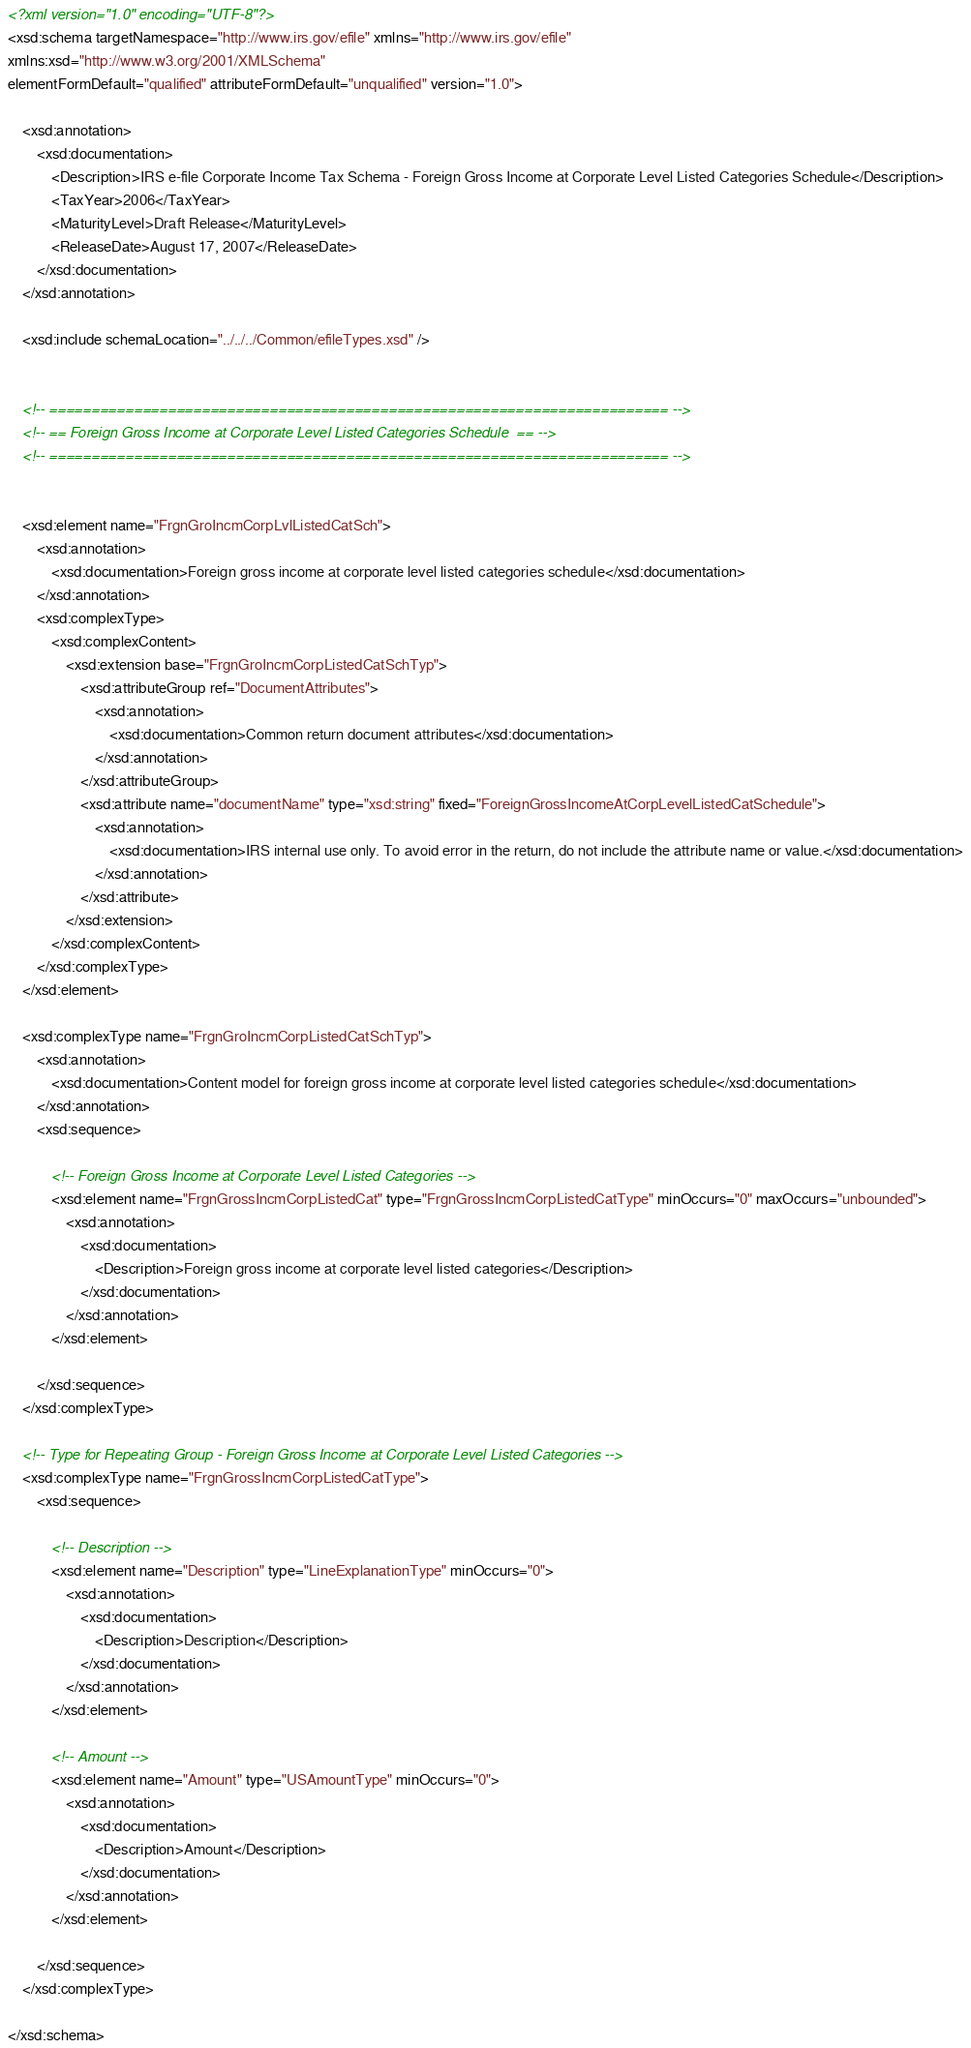<code> <loc_0><loc_0><loc_500><loc_500><_XML_><?xml version="1.0" encoding="UTF-8"?>
<xsd:schema targetNamespace="http://www.irs.gov/efile" xmlns="http://www.irs.gov/efile" 
xmlns:xsd="http://www.w3.org/2001/XMLSchema" 
elementFormDefault="qualified" attributeFormDefault="unqualified" version="1.0">

	<xsd:annotation>
		<xsd:documentation>
			<Description>IRS e-file Corporate Income Tax Schema - Foreign Gross Income at Corporate Level Listed Categories Schedule</Description>
			<TaxYear>2006</TaxYear>
			<MaturityLevel>Draft Release</MaturityLevel>
			<ReleaseDate>August 17, 2007</ReleaseDate>
		</xsd:documentation>
	</xsd:annotation>

	<xsd:include schemaLocation="../../../Common/efileTypes.xsd" />


	<!-- ========================================================================= -->
	<!-- == Foreign Gross Income at Corporate Level Listed Categories Schedule  == -->
	<!-- ========================================================================= -->


	<xsd:element name="FrgnGroIncmCorpLvlListedCatSch">
		<xsd:annotation>
			<xsd:documentation>Foreign gross income at corporate level listed categories schedule</xsd:documentation>
		</xsd:annotation>
		<xsd:complexType>
			<xsd:complexContent>
				<xsd:extension base="FrgnGroIncmCorpListedCatSchTyp">
					<xsd:attributeGroup ref="DocumentAttributes">
						<xsd:annotation>
							<xsd:documentation>Common return document attributes</xsd:documentation>
						</xsd:annotation>
					</xsd:attributeGroup>
					<xsd:attribute name="documentName" type="xsd:string" fixed="ForeignGrossIncomeAtCorpLevelListedCatSchedule">
						<xsd:annotation>
							<xsd:documentation>IRS internal use only. To avoid error in the return, do not include the attribute name or value.</xsd:documentation>
						</xsd:annotation>
					</xsd:attribute>
				</xsd:extension>
			</xsd:complexContent>
		</xsd:complexType>
	</xsd:element>	
	
	<xsd:complexType name="FrgnGroIncmCorpListedCatSchTyp">
		<xsd:annotation>
			<xsd:documentation>Content model for foreign gross income at corporate level listed categories schedule</xsd:documentation>
		</xsd:annotation>
		<xsd:sequence>		
				
			<!-- Foreign Gross Income at Corporate Level Listed Categories -->
			<xsd:element name="FrgnGrossIncmCorpListedCat" type="FrgnGrossIncmCorpListedCatType" minOccurs="0" maxOccurs="unbounded">	
				<xsd:annotation>
					<xsd:documentation>
						<Description>Foreign gross income at corporate level listed categories</Description>
					</xsd:documentation>
				</xsd:annotation>
			</xsd:element>
			
		</xsd:sequence>
	</xsd:complexType>		

	<!-- Type for Repeating Group - Foreign Gross Income at Corporate Level Listed Categories -->
	<xsd:complexType name="FrgnGrossIncmCorpListedCatType">
		<xsd:sequence>		
	
			<!-- Description -->
			<xsd:element name="Description" type="LineExplanationType" minOccurs="0">
				<xsd:annotation>
					<xsd:documentation>
						<Description>Description</Description>
					</xsd:documentation>
				</xsd:annotation>
			</xsd:element>
			
			<!-- Amount -->
			<xsd:element name="Amount" type="USAmountType" minOccurs="0">
				<xsd:annotation>
					<xsd:documentation>
						<Description>Amount</Description>
					</xsd:documentation>
				</xsd:annotation>
			</xsd:element>	
						
		</xsd:sequence>
	</xsd:complexType>	
	
</xsd:schema>
</code> 